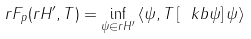Convert formula to latex. <formula><loc_0><loc_0><loc_500><loc_500>r { F } _ { p } ( r { H } ^ { \prime } , T ) = \inf _ { \psi \in r { H } ^ { \prime } } \left \langle \psi , T \left [ \ k b { \psi } \right ] \psi \right \rangle</formula> 